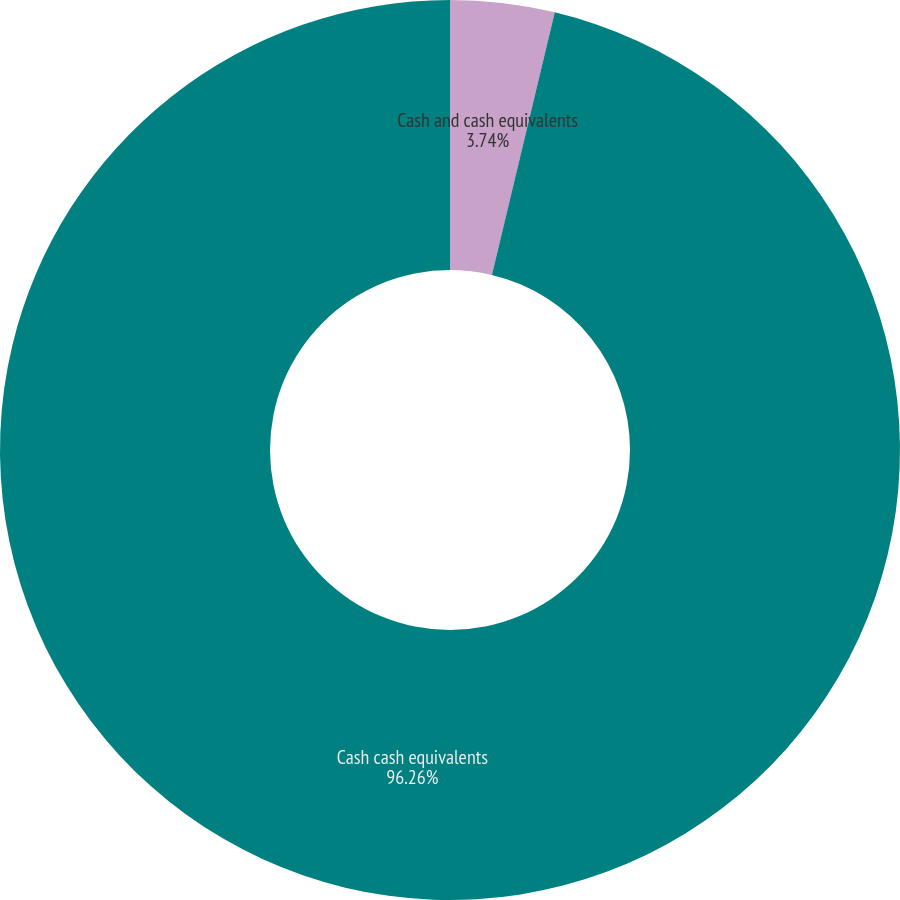Convert chart. <chart><loc_0><loc_0><loc_500><loc_500><pie_chart><fcel>Cash and cash equivalents<fcel>Cash cash equivalents<nl><fcel>3.74%<fcel>96.26%<nl></chart> 